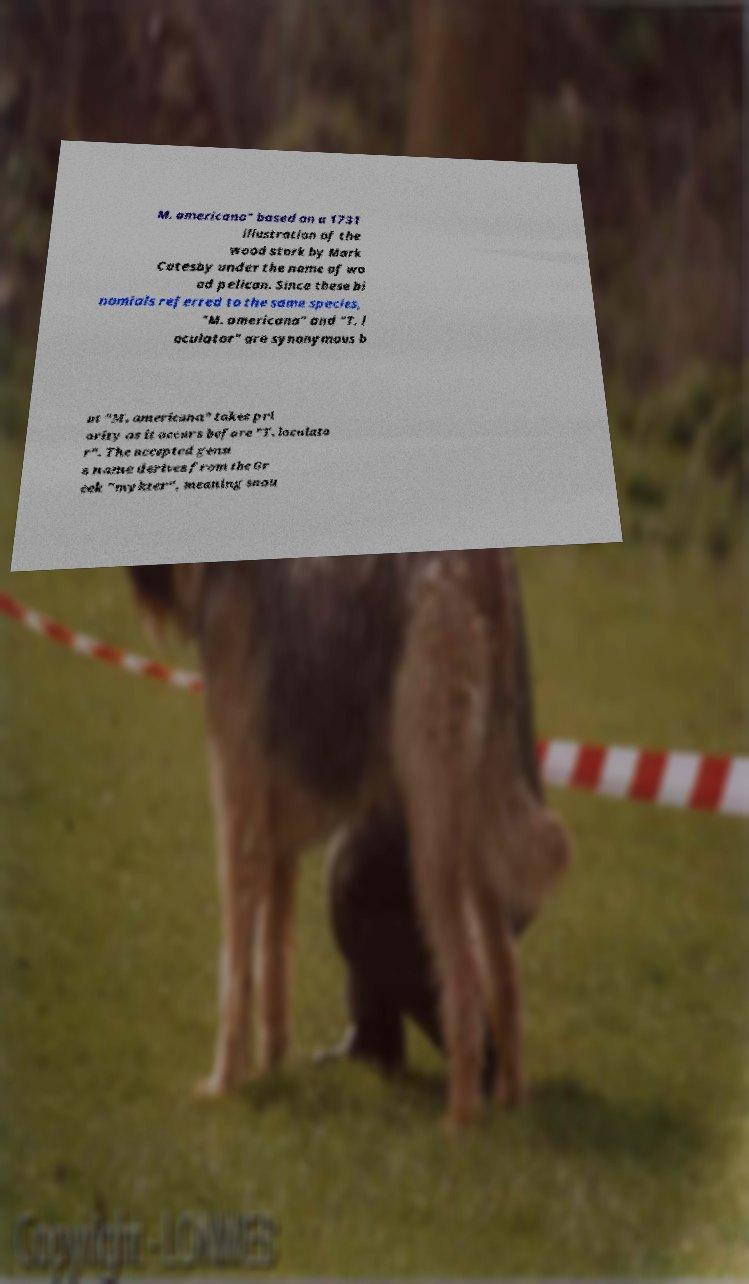Can you read and provide the text displayed in the image?This photo seems to have some interesting text. Can you extract and type it out for me? M. americana" based on a 1731 illustration of the wood stork by Mark Catesby under the name of wo od pelican. Since these bi nomials referred to the same species, "M. americana" and "T. l oculator" are synonymous b ut "M. americana" takes pri ority as it occurs before "T. loculato r". The accepted genu s name derives from the Gr eek "mykter", meaning snou 